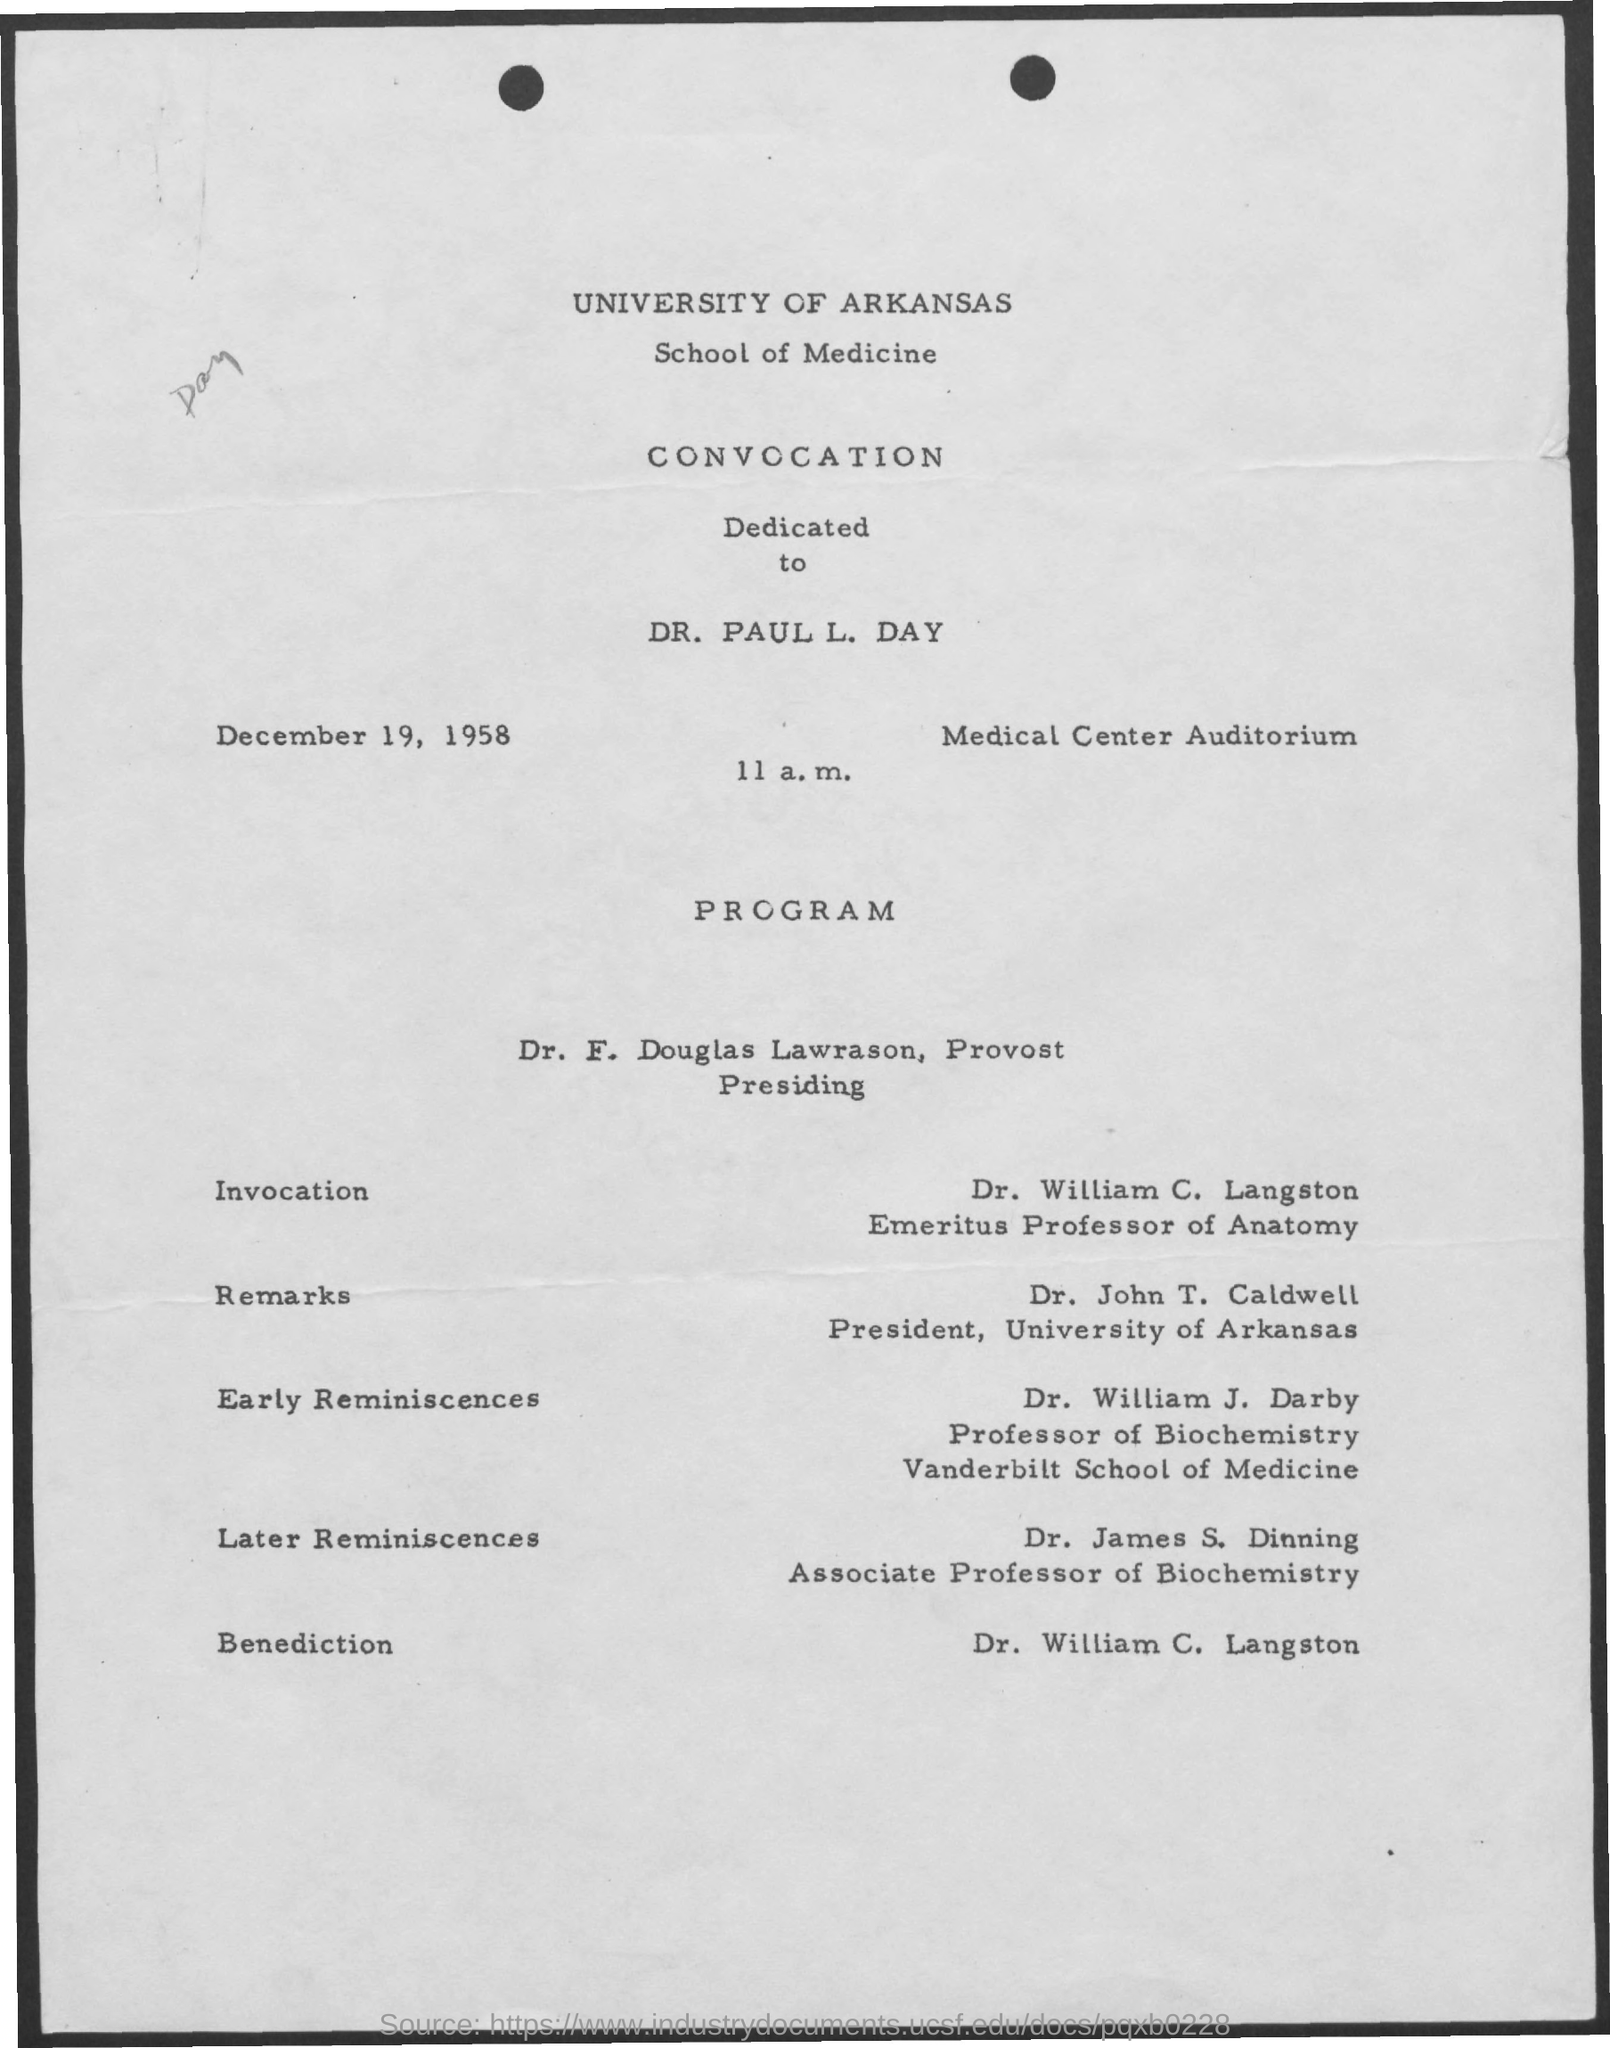What is the date mentioned in the document?
Make the answer very short. December 19, 1958. At what time on December 19 is the convocation?
Provide a short and direct response. 11 a.m. Where is the venue?
Ensure brevity in your answer.  Medical Center Auditorium. What is the designation of William C. Langston?
Offer a very short reply. Emeritus professor of anatomy. 